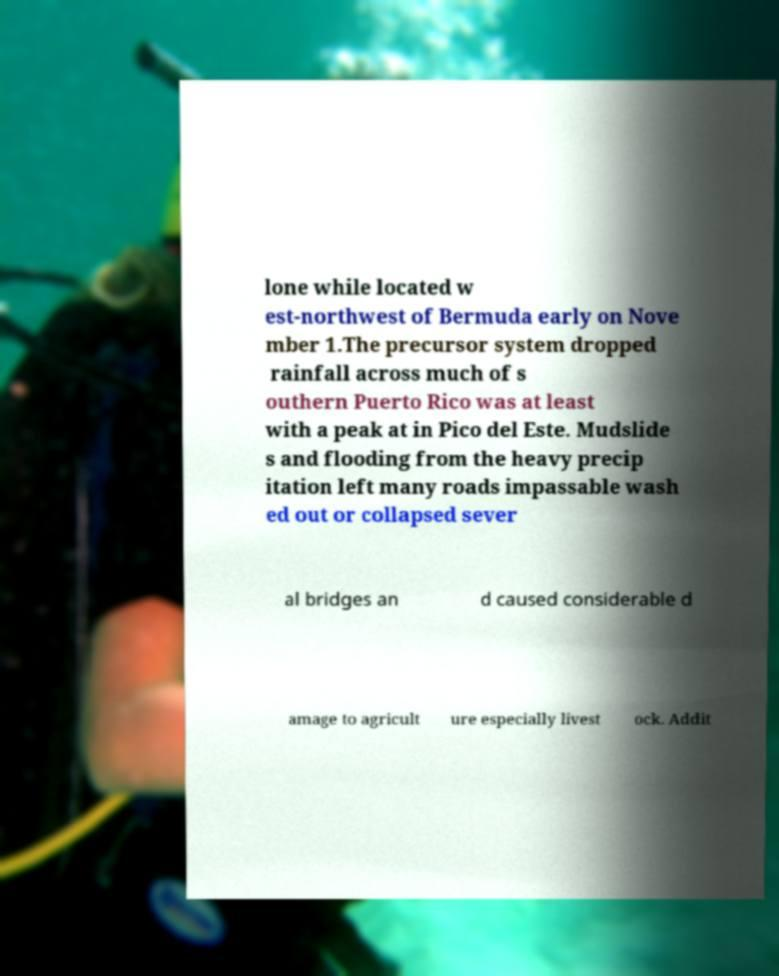Please identify and transcribe the text found in this image. lone while located w est-northwest of Bermuda early on Nove mber 1.The precursor system dropped rainfall across much of s outhern Puerto Rico was at least with a peak at in Pico del Este. Mudslide s and flooding from the heavy precip itation left many roads impassable wash ed out or collapsed sever al bridges an d caused considerable d amage to agricult ure especially livest ock. Addit 